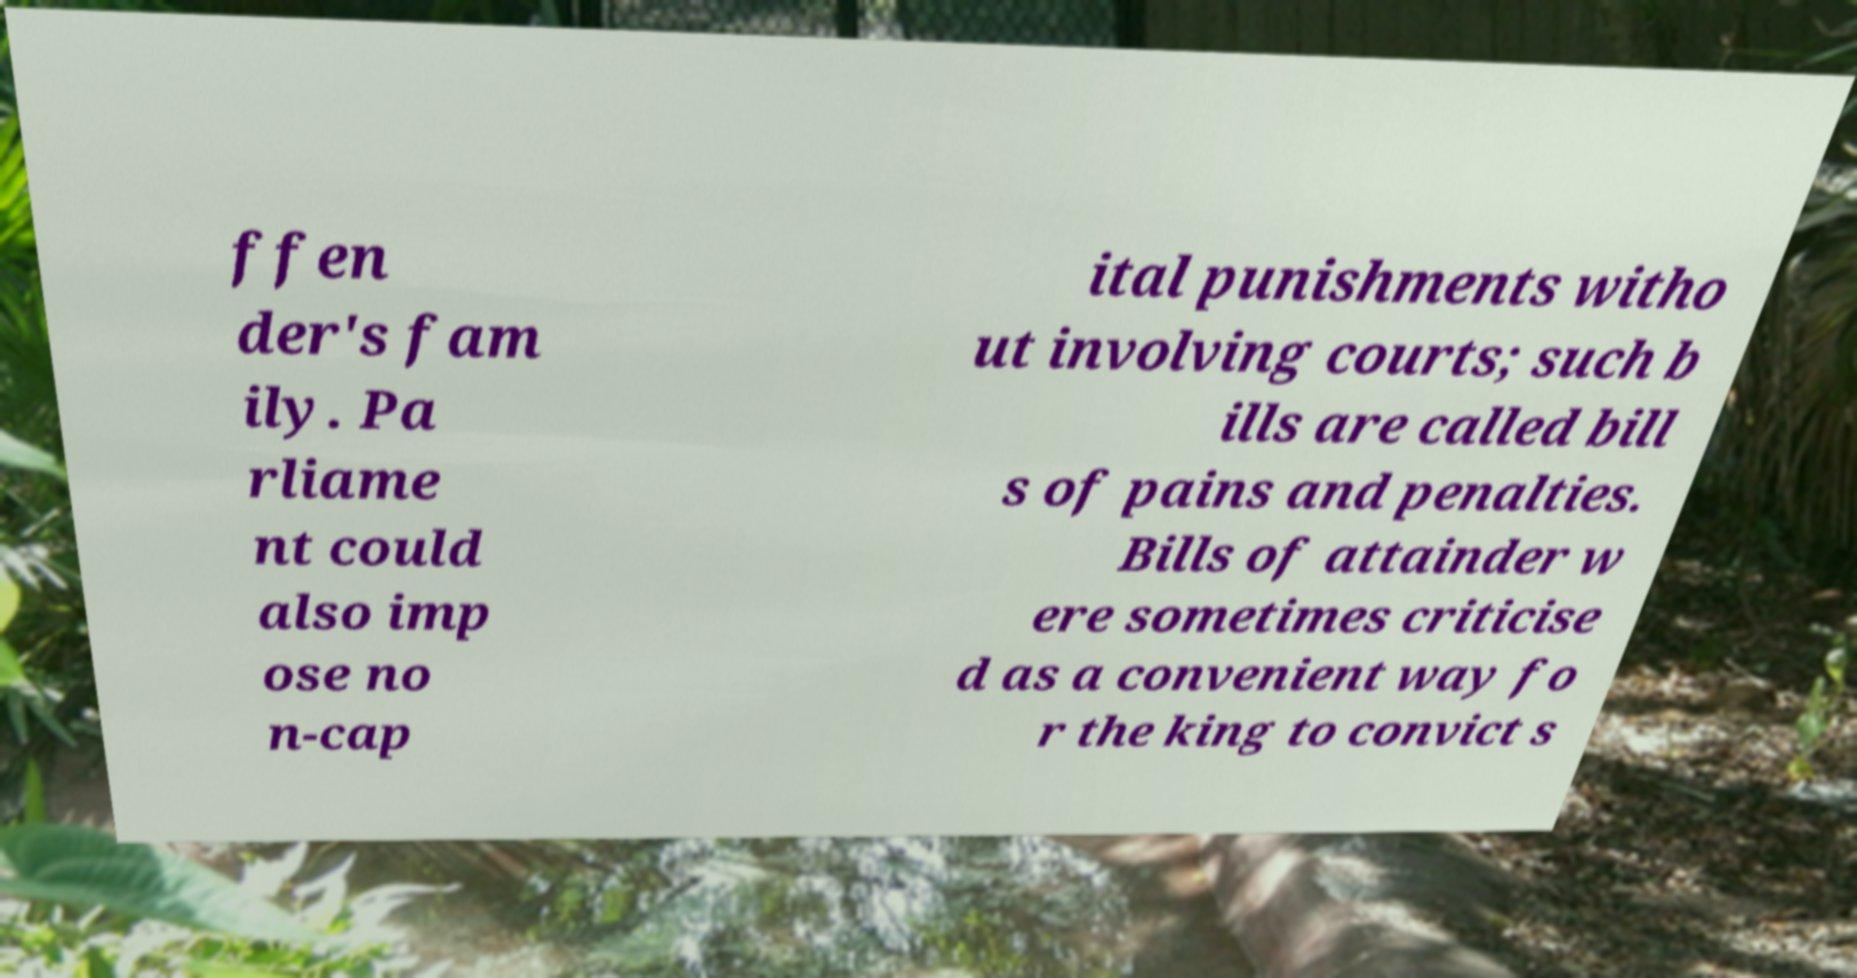For documentation purposes, I need the text within this image transcribed. Could you provide that? ffen der's fam ily. Pa rliame nt could also imp ose no n-cap ital punishments witho ut involving courts; such b ills are called bill s of pains and penalties. Bills of attainder w ere sometimes criticise d as a convenient way fo r the king to convict s 